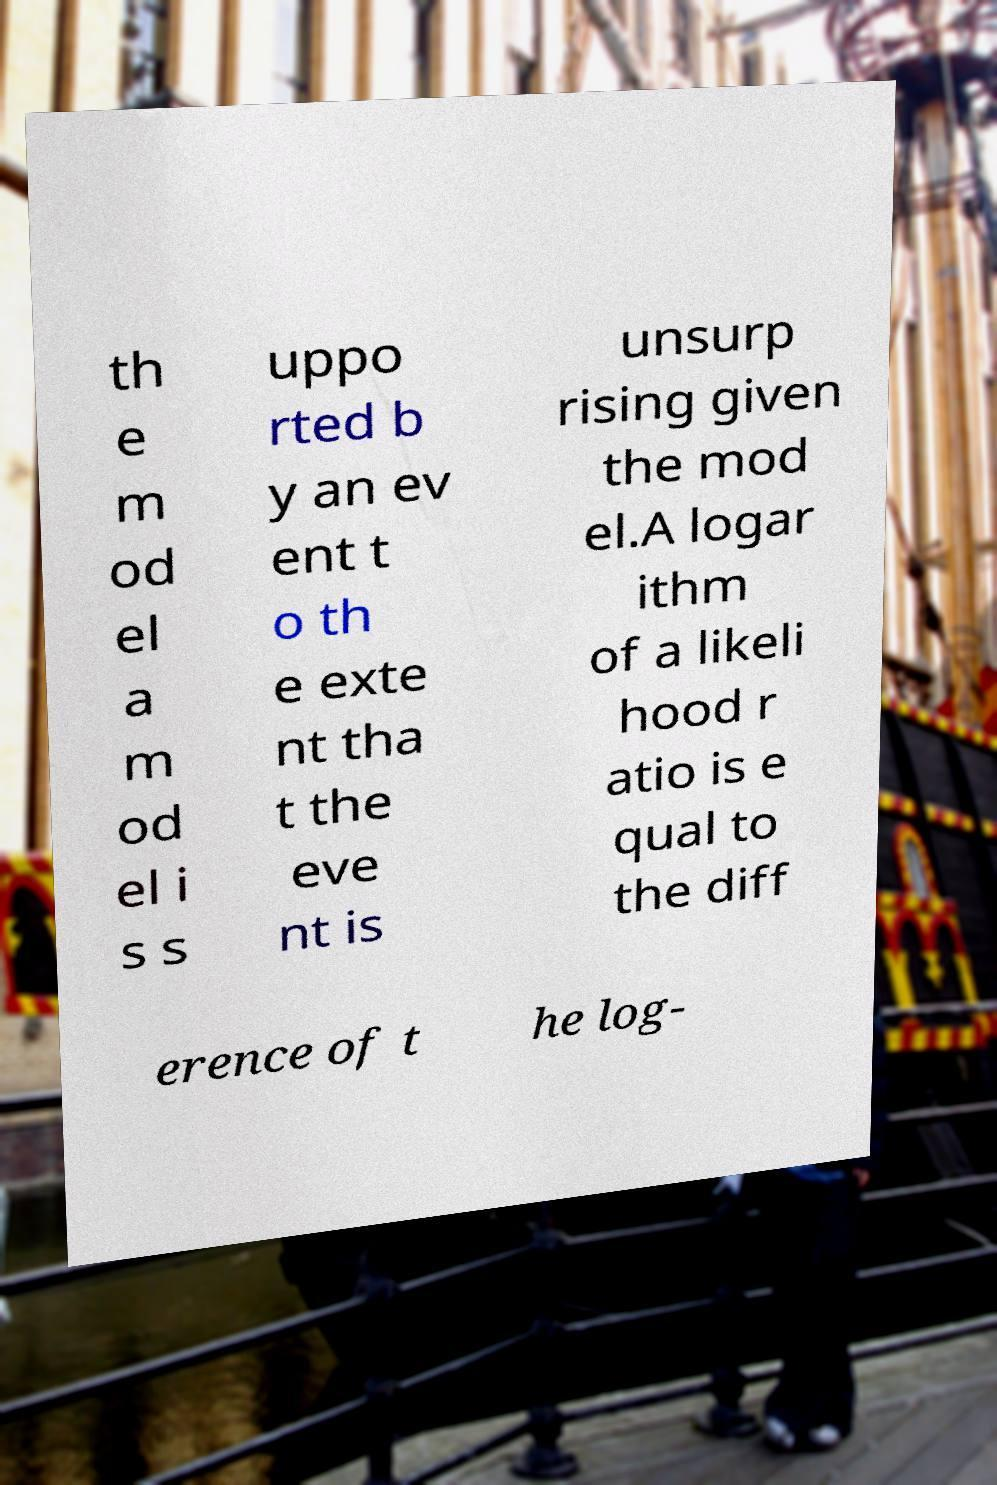Could you assist in decoding the text presented in this image and type it out clearly? th e m od el a m od el i s s uppo rted b y an ev ent t o th e exte nt tha t the eve nt is unsurp rising given the mod el.A logar ithm of a likeli hood r atio is e qual to the diff erence of t he log- 